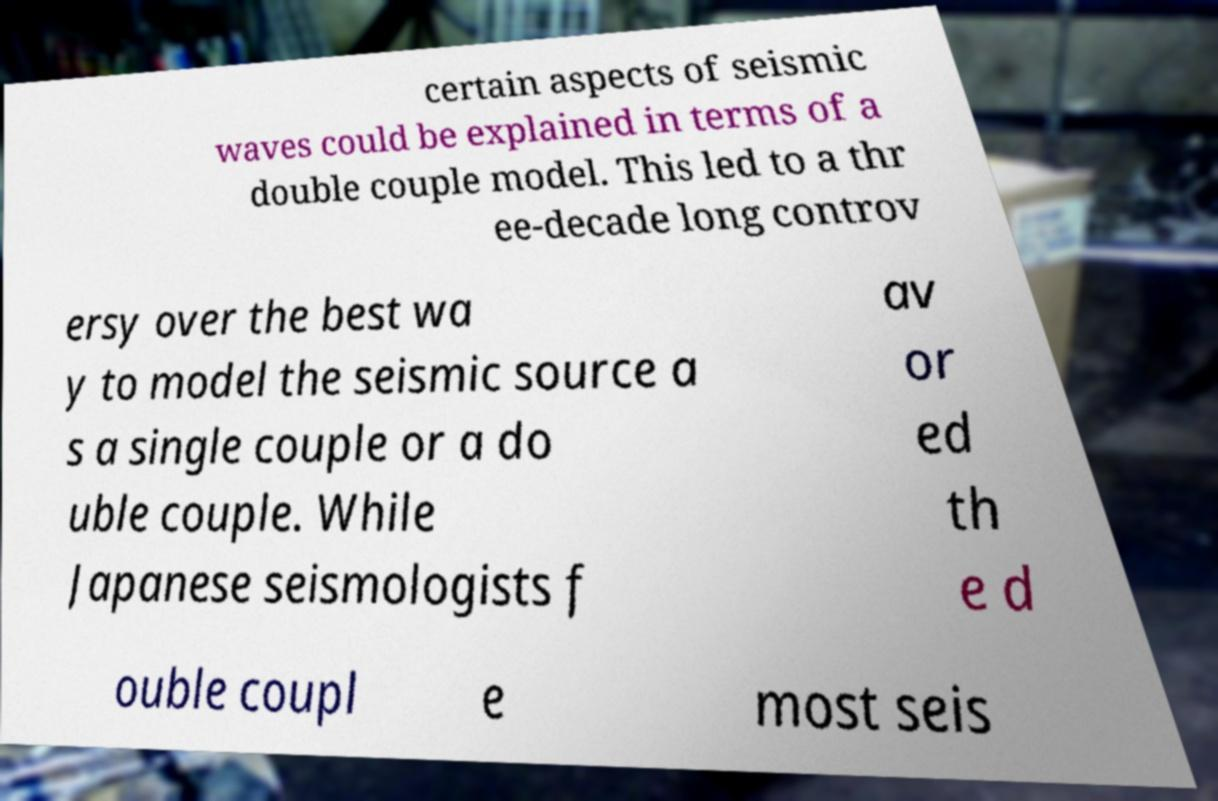Please read and relay the text visible in this image. What does it say? certain aspects of seismic waves could be explained in terms of a double couple model. This led to a thr ee-decade long controv ersy over the best wa y to model the seismic source a s a single couple or a do uble couple. While Japanese seismologists f av or ed th e d ouble coupl e most seis 